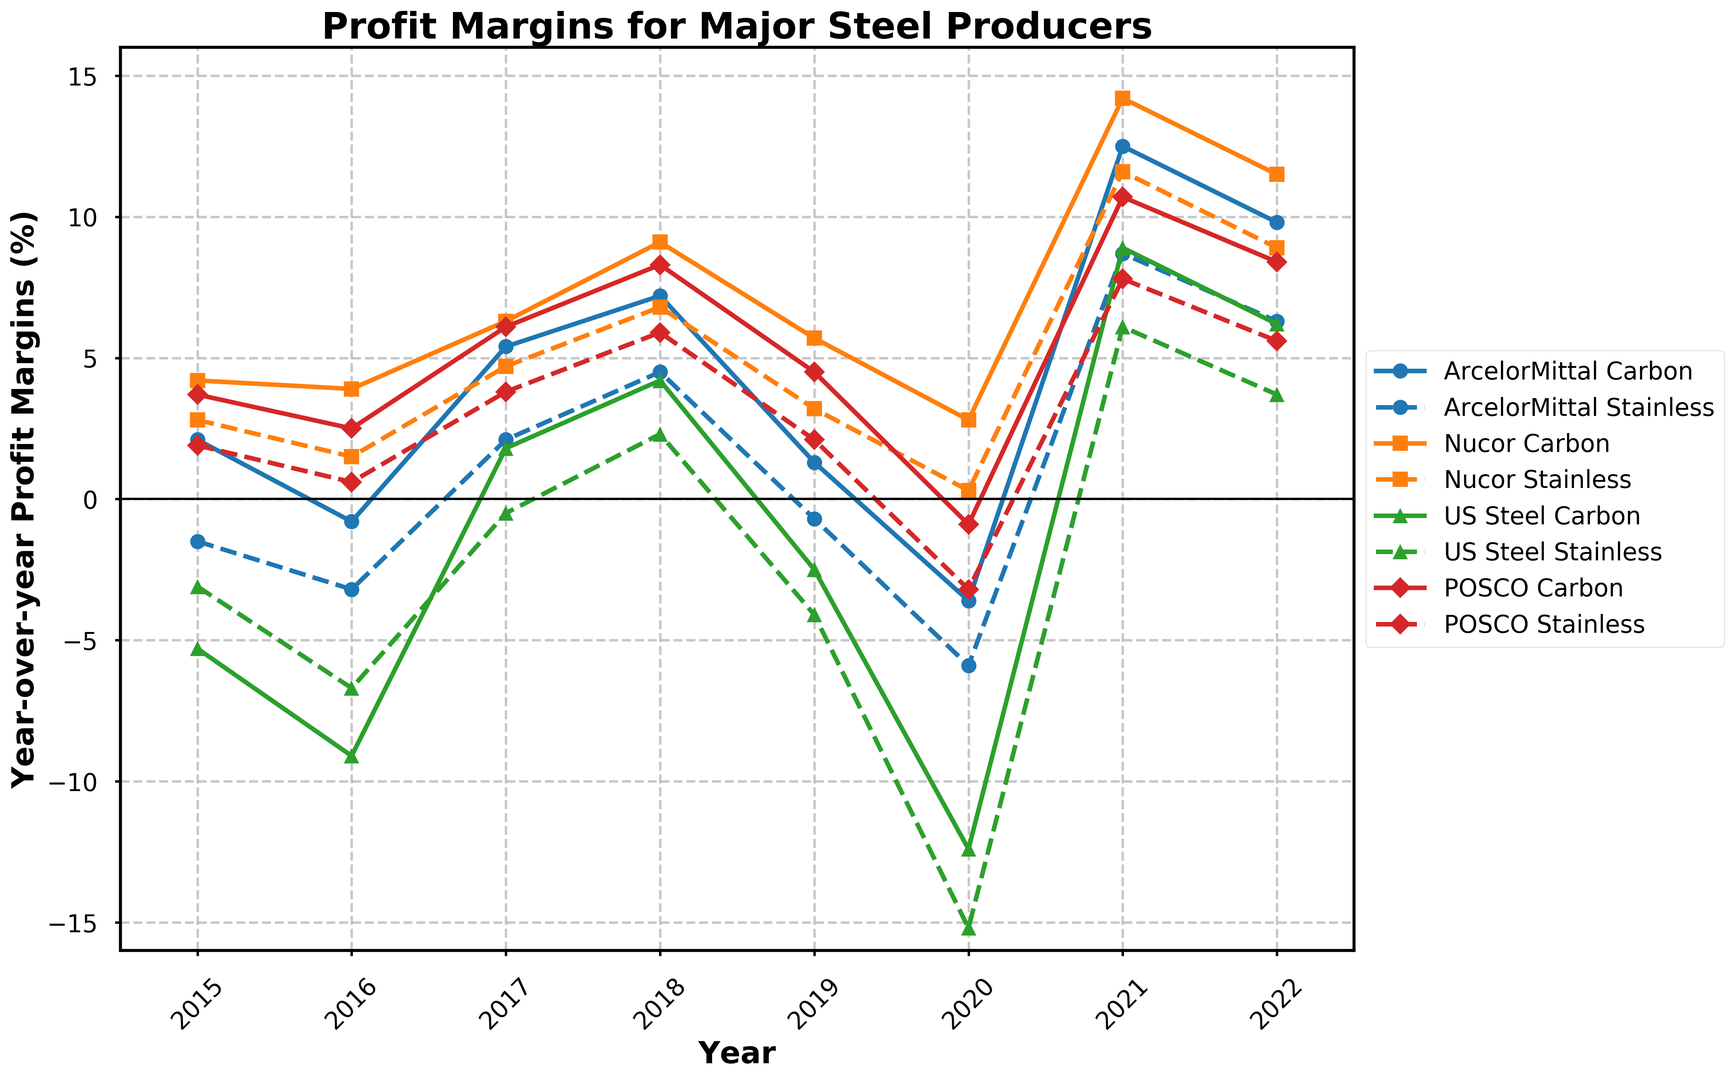What is the trend for POSCO's profit margins from 2015 to 2022 for both carbon steel and stainless steel? Both the carbon steel and stainless steel profit margins of POSCO show an overall increasing trend from 2015 to 2022. For carbon steel, the profit margins start at 3.7% in 2015 and rise to 8.4% in 2022. For stainless steel, they start at 1.9% in 2015 and increase to 5.6% in 2022.
Answer: Increasing How does US Steel's profit margin for carbon steel compare from 2016 to 2020? In 2016, US Steel's profit margin for carbon steel is -9.1%. It increases to 1.8% in 2017, further to 4.2% in 2018, then drops to -2.5% in 2019 and -12.4% in 2020. Therefore, after an initial increase from 2016 to 2018, it decreases significantly by 2020.
Answer: Initial increase, significant decrease Among the four companies, which one had the highest profit margin for carbon steel in 2021? For 2021, the profit margins for carbon steel are 12.5% for ArcelorMittal, 14.2% for Nucor, 8.9% for US Steel, and 10.7% for POSCO. Among these, Nucor has the highest profit margin for carbon steel.
Answer: Nucor What is the average profit margin of Nucor for stainless steel between 2015 and 2022? The profit margins for Nucor's stainless steel from 2015 to 2022 are 2.8%, 1.5%, 4.7%, 6.8%, 3.2%, 0.3%, 11.6%, and 8.9%. Adding these values gives a total of 39.8%. Dividing by the number of years (8) gives an average of 4.975%.
Answer: 4.975% For which year did ArcelorMittal have the largest year-over-year increase in profit margins for stainless steel? Observing the changes year-over-year for ArcelorMittal's stainless steel: -1.5% to -3.2% (decrease), -3.2% to 2.1% (increase by 5.3%), 2.1% to 4.5% (increase by 2.4%), 4.5% to -0.7% (decrease), -0.7% to -5.9% (decrease), -5.9% to 8.7% (increase by 14.6%), 8.7% to 6.3% (decrease). The largest year-over-year increase is from 2020 to 2021 with an increase of 14.6%.
Answer: 2021 Compare ArcelorMittal and Nucor's profit margins for carbon steel and stainless steel in 2018. Which company performed better in each category? In 2018, ArcelorMittal's profit margins are 7.2% for carbon steel and 4.5% for stainless steel. Nucor's profit margins are 9.1% for carbon steel and 6.8% for stainless steel. Therefore, Nucor outperformed ArcelorMittal in both categories in 2018.
Answer: Nucor for both Which company had the most volatile profit margins for stainless steel between 2015 and 2022? Volatility can be visually assessed as the range or fluctuations in the plotted lines. ArcelorMittal's stainless steel profit margin fluctuates from -1.5% to 8.7%, Nucor from 2.8% to 11.6%, US Steel from -3.1% to 6.1%, and POSCO from 1.9% to 7.8%. ArcelorMittal shows the highest range and thus, the most volatility.
Answer: ArcelorMittal If you were to invest only based on the 2022 stainless steel profit margins, which company appears most promising? In 2022, the stainless steel profit margins are 6.3% for ArcelorMittal, 8.9% for Nucor, 3.7% for US Steel, and 5.6% for POSCO. Nucor has the highest profit margin for stainless steel, making it appear most promising for investment based solely on 2022 data.
Answer: Nucor 